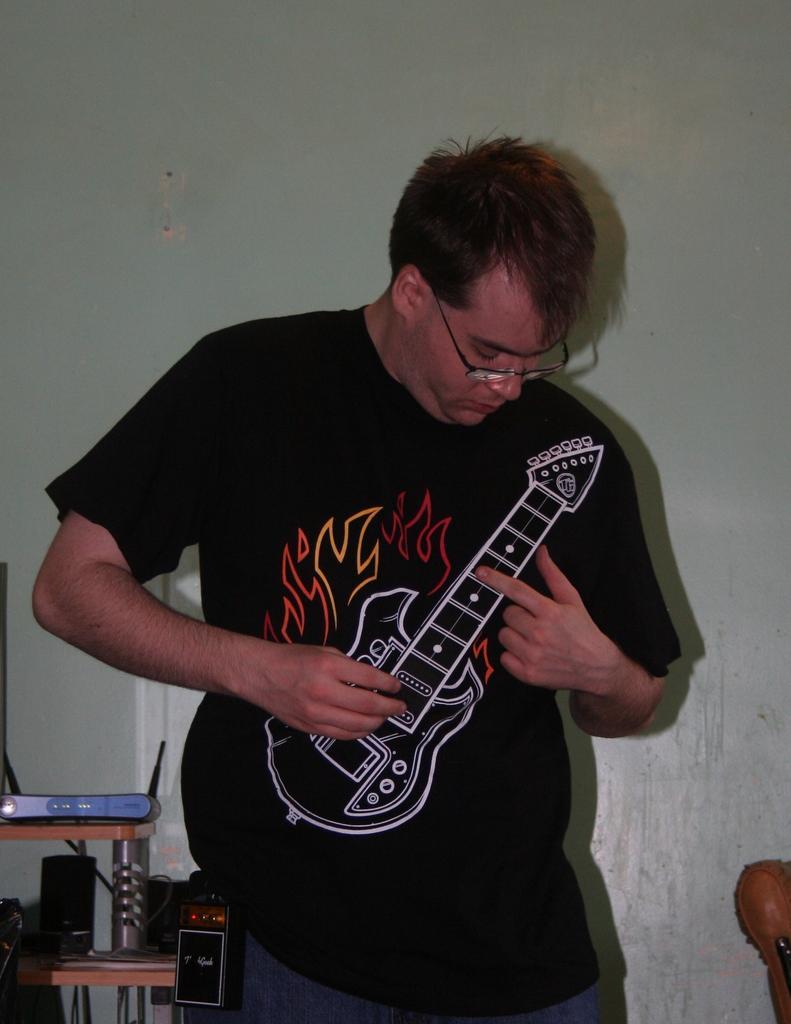Can you describe this image briefly? In this image in the center there is one man who is standing and on the left side there are some speakers and one table, in the background there is a wall. 